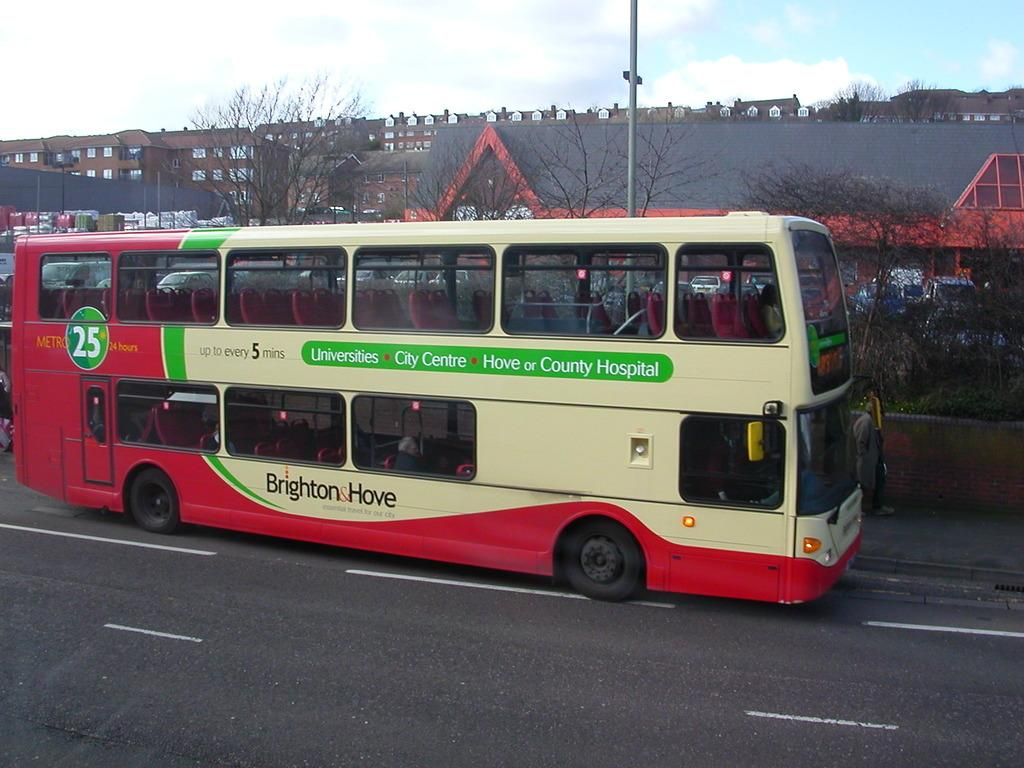<image>
Give a short and clear explanation of the subsequent image. A Brighton and Hove bus has the number 25 in a green circle on it. 